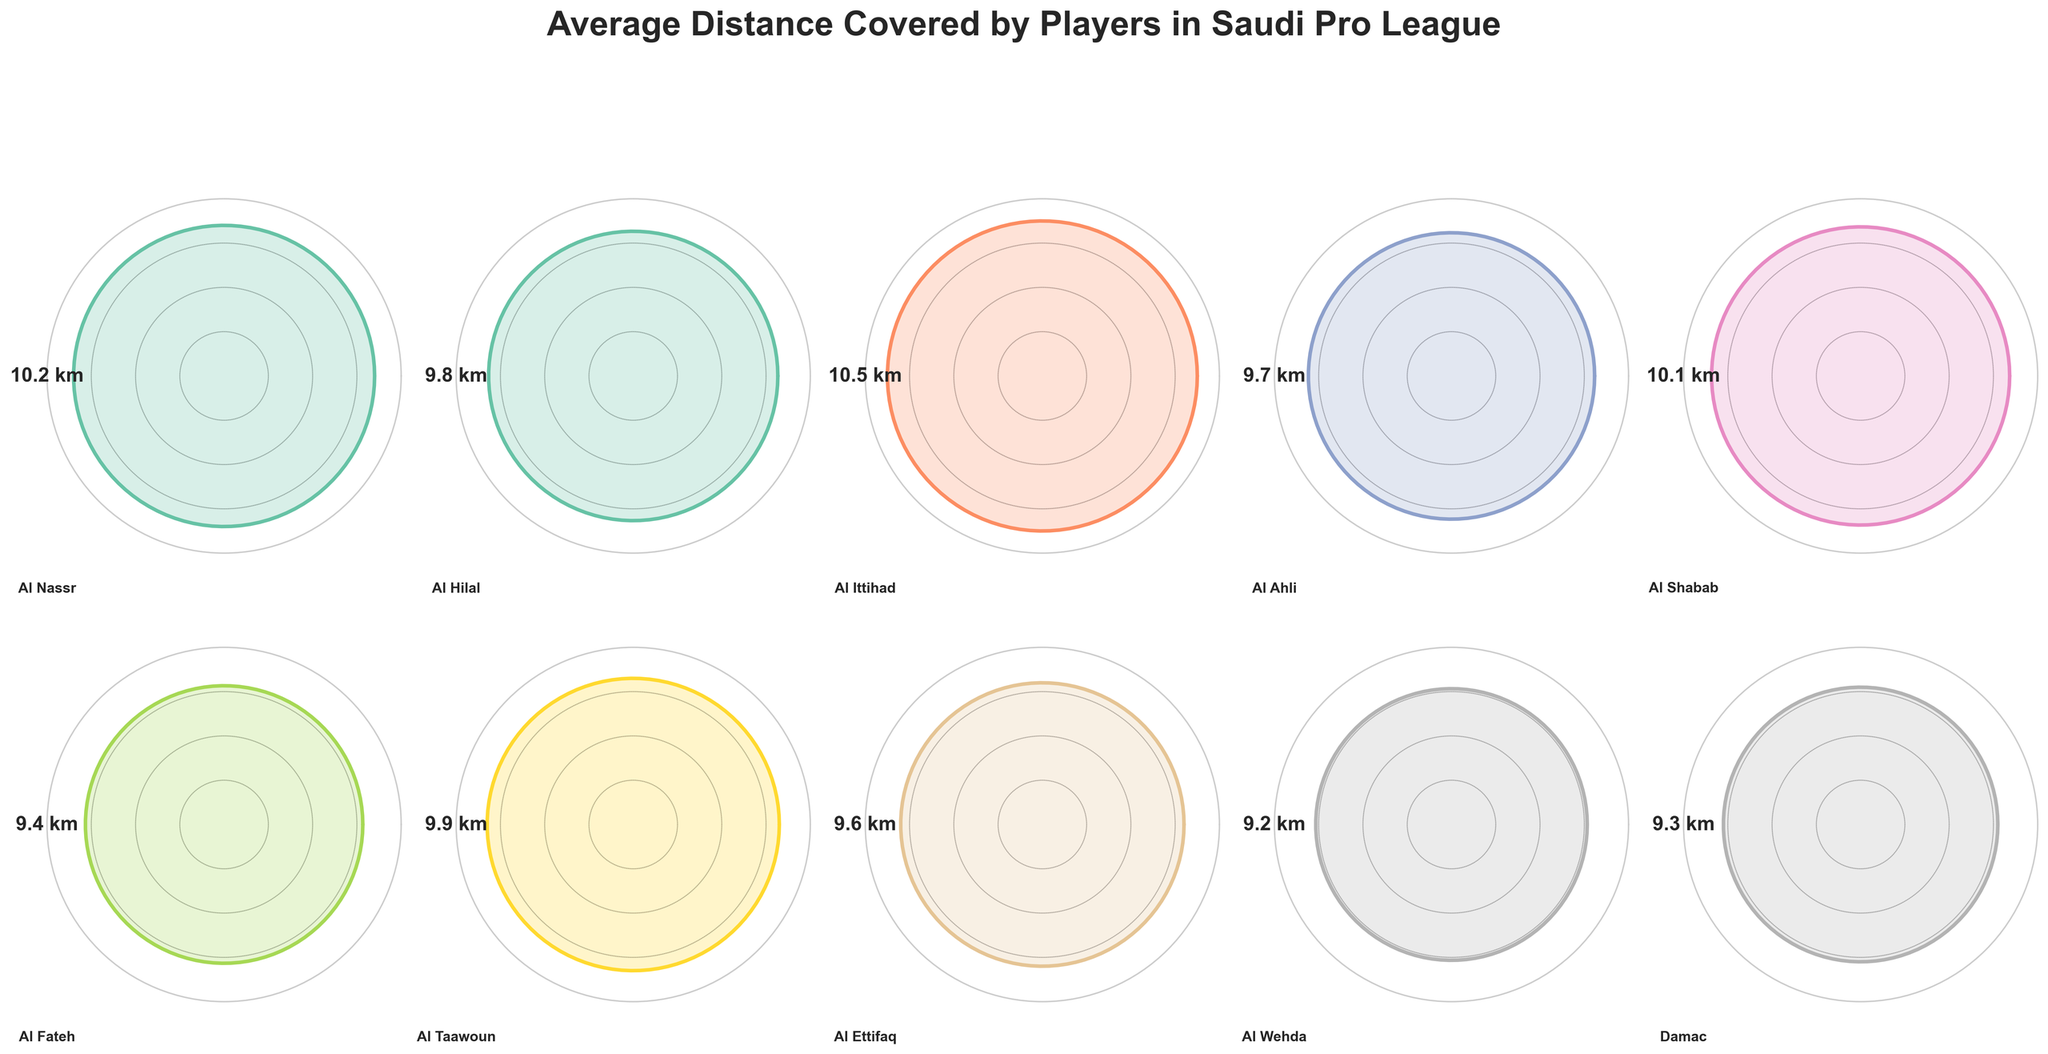What's the title of the figure? The title is displayed at the top of the figure. It reads "Average Distance Covered by Players in Saudi Pro League."
Answer: Average Distance Covered by Players in Saudi Pro League How many subplots are there in the figure? The figure consists of a grid of subplots, with 2 rows and 5 columns, resulting in 10 subplots in total. However, as data for only 10 teams is provided, all subplots are used.
Answer: 10 Which player covers the highest average distance? By looking at the distances displayed in the subplots, Karim Benzema from Al Ittihad covers the highest distance of 10.5 km.
Answer: Karim Benzema Which player covers the lowest average distance? By examining the distances in each subplot, Anselmo from Al Wehda covers the lowest distance of 9.2 km.
Answer: Anselmo What is the average distance covered by Cristiano Ronaldo? The subplot for Al Nassr shows Cristiano Ronaldo's distance as 10.2 km.
Answer: 10.2 km Who covers more distance on average, Riyad Mahrez or Salem Al-Dawsari? Riyad Mahrez covers 9.7 km and Salem Al-Dawsari covers 9.8 km, so Salem Al-Dawsari covers more distance.
Answer: Salem Al-Dawsari What is the combined distance covered by Mitchell Te Vrede and Emilio Zelaya? Mitchell Te Vrede covers 9.4 km and Emilio Zelaya covers 9.3 km. Adding these, 9.4 + 9.3 = 18.7 km.
Answer: 18.7 km What is the difference in the average distance covered between Ever Banega and Robin Quaison? Ever Banega covers 10.1 km and Robin Quaison covers 9.6 km, so the difference is 10.1 - 9.6 = 0.5 km.
Answer: 0.5 km Rank the players based on their average distance covered from highest to lowest. Based on the distances displayed in the subplots:
1. Karim Benzema - 10.5 km
2. Cristiano Ronaldo - 10.2 km
3. Ever Banega - 10.1 km
4. Léandre Tawamba - 9.9 km
5. Salem Al-Dawsari - 9.8 km
6. Riyad Mahrez - 9.7 km
7. Robin Quaison - 9.6 km
8. Mitchell Te Vrede - 9.4 km
9. Emilio Zelaya - 9.3 km
10. Anselmo - 9.2 km
Answer: Karim Benzema, Cristiano Ronaldo, Ever Banega, Léandre Tawamba, Salem Al-Dawsari, Riyad Mahrez, Robin Quaison, Mitchell Te Vrede, Emilio Zelaya, Anselmo 